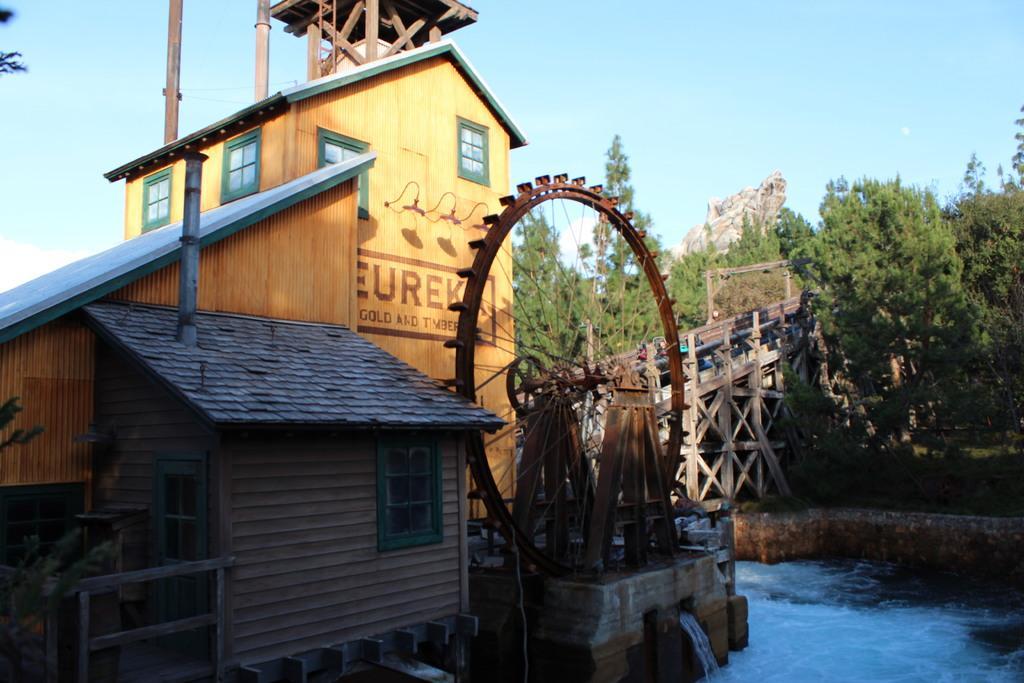In one or two sentences, can you explain what this image depicts? In this image there is a building, in front of that there is a some circular machine from which there is a water flow, beside that there water there is a bridge and trees. 